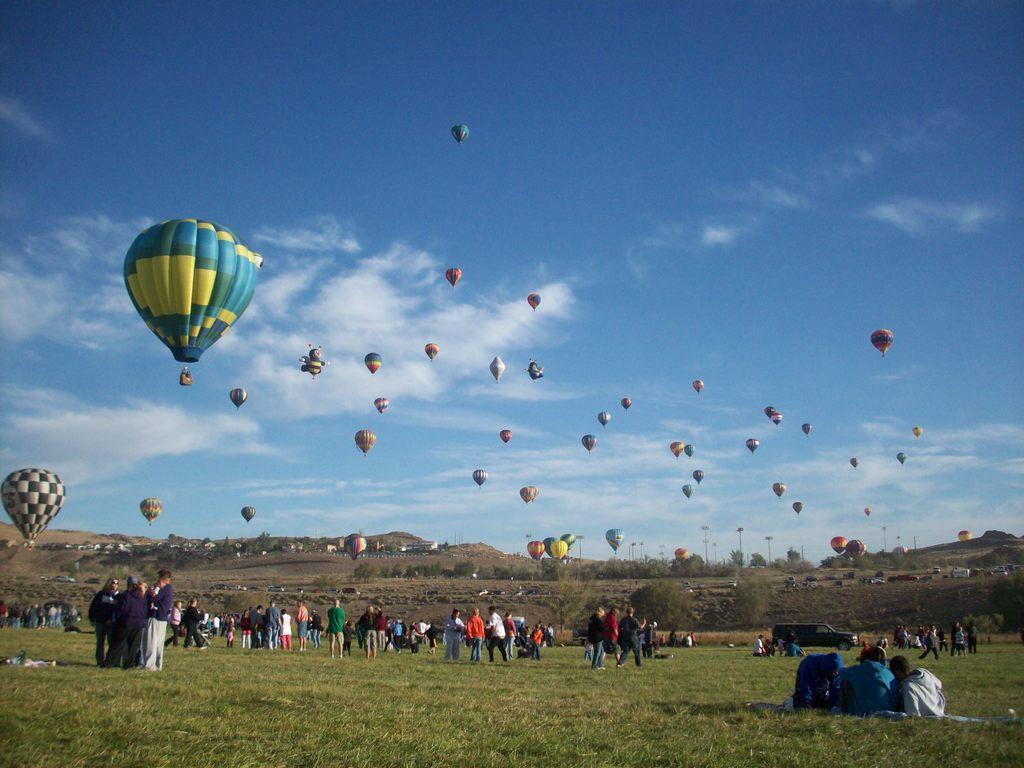Describe this image in one or two sentences. In this picture I can see so many people are on the grass and we can see some parachutes are in the air. 